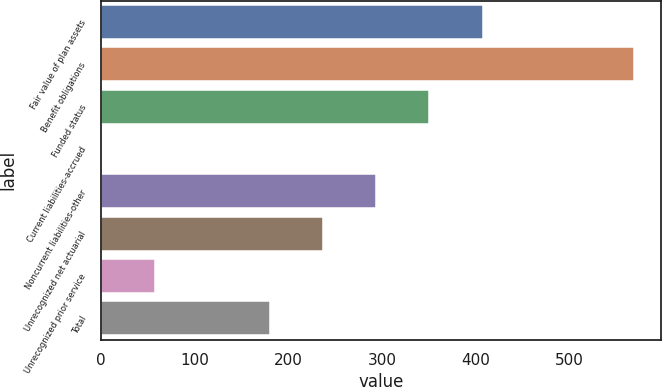Convert chart to OTSL. <chart><loc_0><loc_0><loc_500><loc_500><bar_chart><fcel>Fair value of plan assets<fcel>Benefit obligations<fcel>Funded status<fcel>Current liabilities-accrued<fcel>Noncurrent liabilities-other<fcel>Unrecognized net actuarial<fcel>Unrecognized prior service<fcel>Total<nl><fcel>407.6<fcel>570<fcel>350.7<fcel>1<fcel>293.8<fcel>236.9<fcel>57.9<fcel>180<nl></chart> 